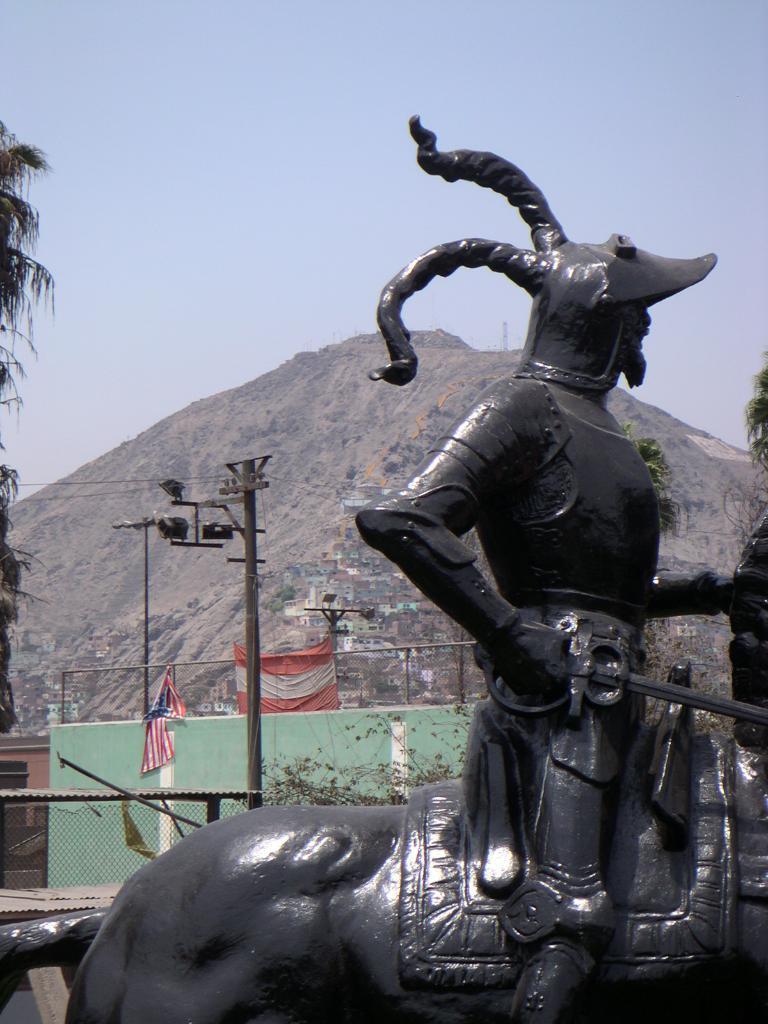How would you summarize this image in a sentence or two? In this given image, We can see a sculpture statue and a animal sitting on it towards the left, We can see a tree in middle, We can see an electrical iron pole which include the wires, lights after that, We can see a mountain, tree. 